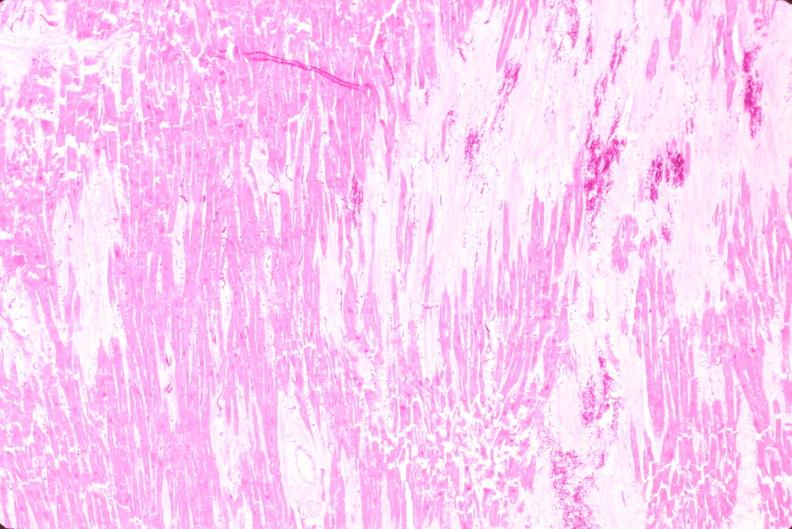what is present?
Answer the question using a single word or phrase. Cardiovascular 